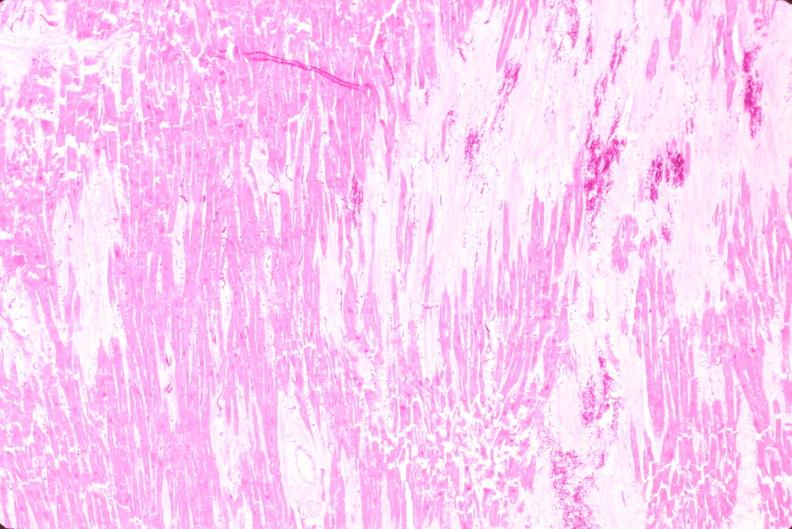what is present?
Answer the question using a single word or phrase. Cardiovascular 